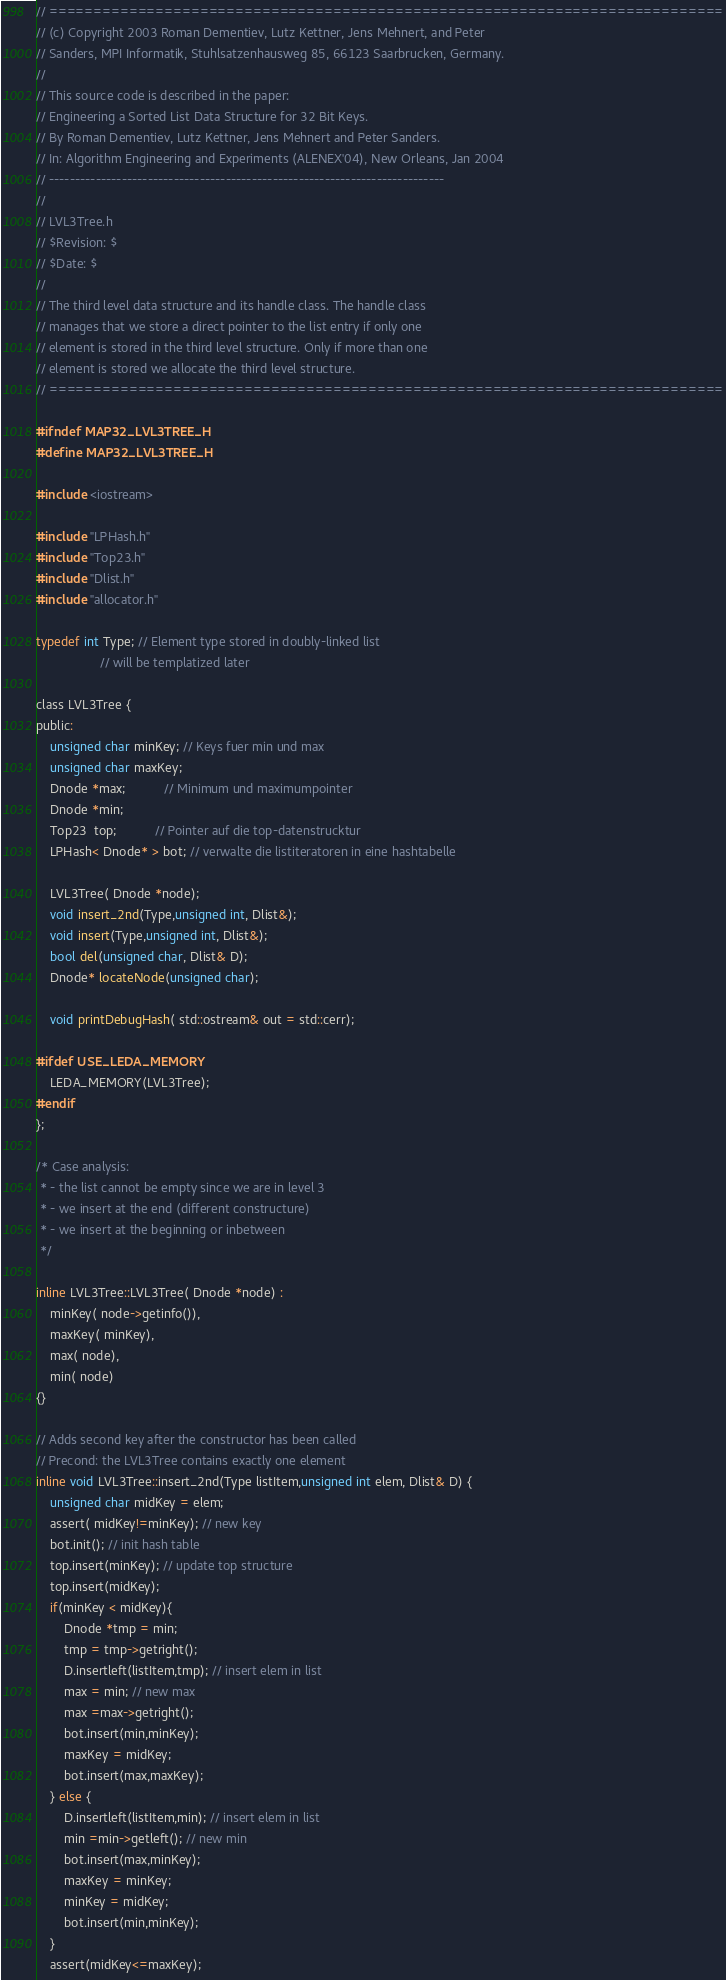Convert code to text. <code><loc_0><loc_0><loc_500><loc_500><_C_>// ============================================================================
// (c) Copyright 2003 Roman Dementiev, Lutz Kettner, Jens Mehnert, and Peter
// Sanders, MPI Informatik, Stuhlsatzenhausweg 85, 66123 Saarbrucken, Germany.
//
// This source code is described in the paper: 
// Engineering a Sorted List Data Structure for 32 Bit Keys.
// By Roman Dementiev, Lutz Kettner, Jens Mehnert and Peter Sanders. 
// In: Algorithm Engineering and Experiments (ALENEX'04), New Orleans, Jan 2004
// ----------------------------------------------------------------------------
//
// LVL3Tree.h
// $Revision: $
// $Date: $
//
// The third level data structure and its handle class. The handle class 
// manages that we store a direct pointer to the list entry if only one 
// element is stored in the third level structure. Only if more than one
// element is stored we allocate the third level structure.
// ============================================================================

#ifndef MAP32_LVL3TREE_H
#define MAP32_LVL3TREE_H

#include <iostream>

#include "LPHash.h"
#include "Top23.h"
#include "Dlist.h"
#include "allocator.h"

typedef int Type; // Element type stored in doubly-linked list
                  // will be templatized later

class LVL3Tree {  
public:
    unsigned char minKey; // Keys fuer min und max
    unsigned char maxKey;
    Dnode *max;           // Minimum und maximumpointer
    Dnode *min;           
    Top23  top;           // Pointer auf die top-datenstrucktur
    LPHash< Dnode* > bot; // verwalte die listiteratoren in eine hashtabelle

    LVL3Tree( Dnode *node);
    void insert_2nd(Type,unsigned int, Dlist&);
    void insert(Type,unsigned int, Dlist&);
    bool del(unsigned char, Dlist& D);
    Dnode* locateNode(unsigned char);

    void printDebugHash( std::ostream& out = std::cerr);

#ifdef USE_LEDA_MEMORY
    LEDA_MEMORY(LVL3Tree);
#endif
};

/* Case analysis:
 * - the list cannot be empty since we are in level 3
 * - we insert at the end (different constructure)
 * - we insert at the beginning or inbetween
 */

inline LVL3Tree::LVL3Tree( Dnode *node) :
    minKey( node->getinfo()),
    maxKey( minKey),
    max( node),
    min( node)
{}

// Adds second key after the constructor has been called
// Precond: the LVL3Tree contains exactly one element
inline void LVL3Tree::insert_2nd(Type listItem,unsigned int elem, Dlist& D) {
    unsigned char midKey = elem;
    assert( midKey!=minKey); // new key
    bot.init(); // init hash table
    top.insert(minKey); // update top structure
    top.insert(midKey);
    if(minKey < midKey){
        Dnode *tmp = min;
        tmp = tmp->getright();
        D.insertleft(listItem,tmp); // insert elem in list
        max = min; // new max
        max =max->getright();   
        bot.insert(min,minKey);
        maxKey = midKey;  
        bot.insert(max,maxKey); 
    } else {
        D.insertleft(listItem,min); // insert elem in list
        min =min->getleft(); // new min
        bot.insert(max,minKey);
        maxKey = minKey;
        minKey = midKey;
        bot.insert(min,minKey);     
    }
    assert(midKey<=maxKey);</code> 